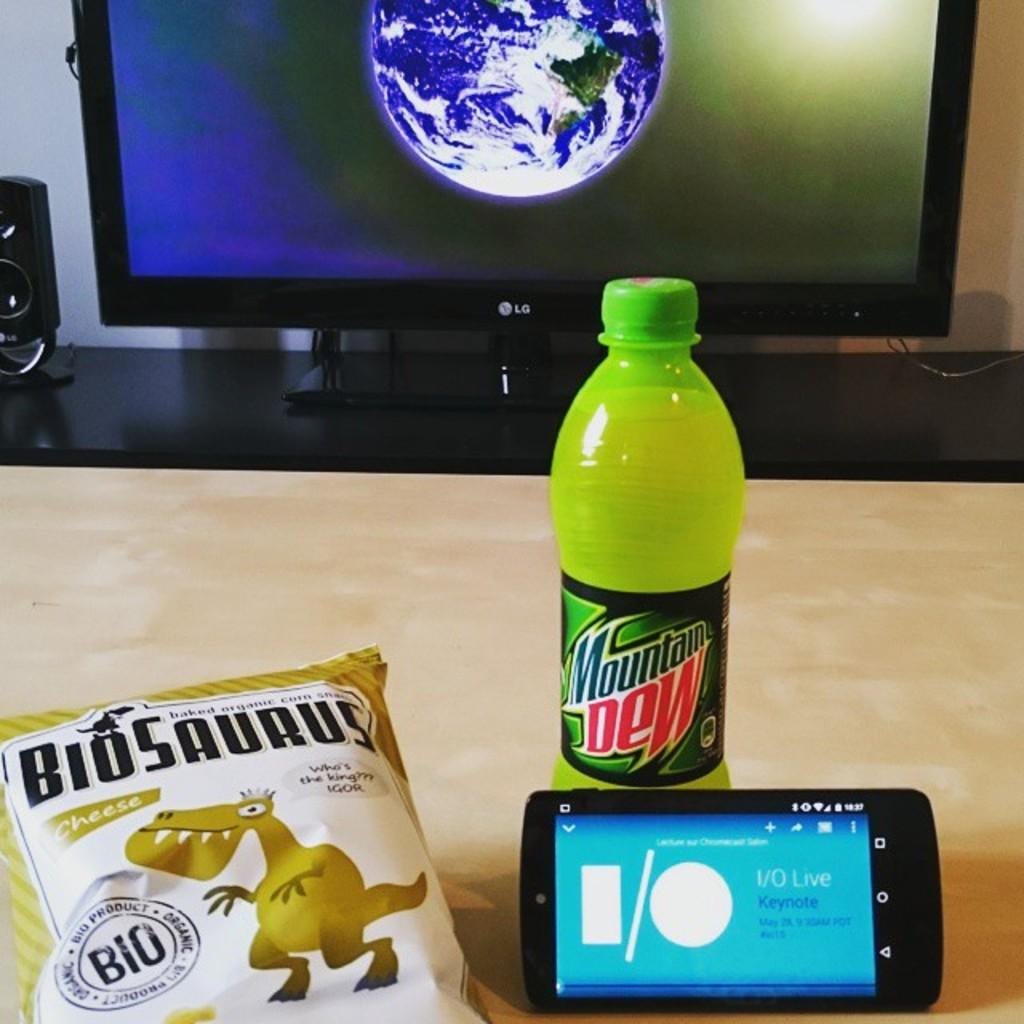What kind of soda is in the bottle?
Provide a succinct answer. Mountain dew. What kind of chips?
Offer a very short reply. Biosaurus. 